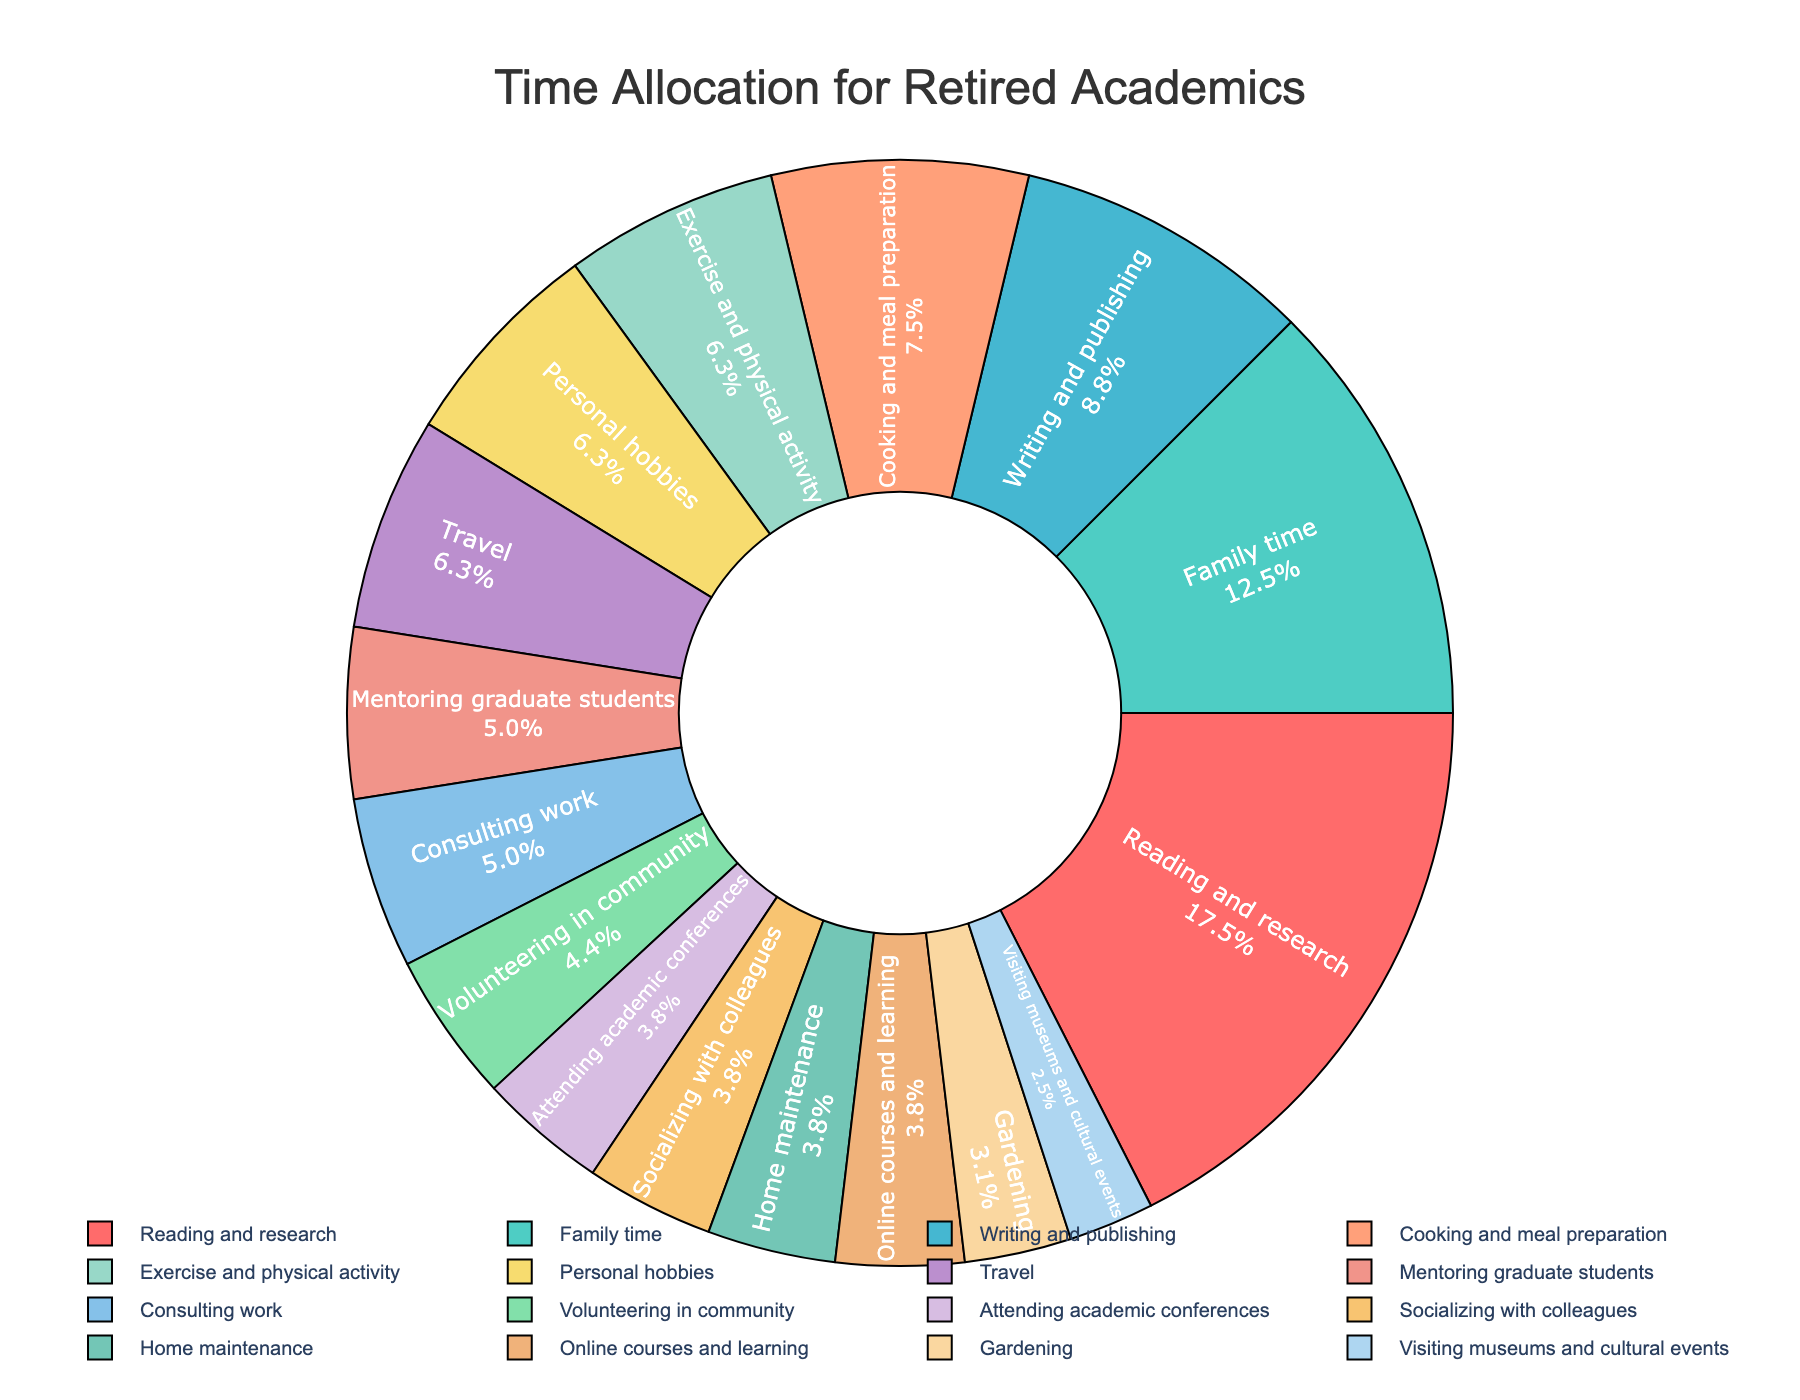What percentage of time is spent on reading and research? The pie chart includes labels that show the percentage of time spent on each activity. Locate the segment labeled "Reading and research," which shows 28 hours allocated. According to the chart, this corresponds to 28%.
Answer: 28% Which activity takes up more time, socializing with colleagues or consulting work? To compare these two activities, check the parts of the pie chart labeled "Socializing with colleagues" and "Consulting work." "Socializing with colleagues" is 6 hours while "Consulting work" is 8 hours, corresponding to a larger portion of the pie for consulting work.
Answer: Consulting work What is the combined percentage of time spent on exercise, personal hobbies, and travel? Identify the segments for "Exercise and physical activity" (10 hours), "Personal hobbies" (10 hours), and "Travel" (10 hours) on the pie chart. Sum these hours (10 + 10 + 10 = 30). Since the total is 100 hours, the combined percentage is (30/100) * 100%.
Answer: 30% What activity has the smallest allocated time and what percentage does this represent? Locate the smallest segment, labeled "Visiting museums and cultural events," which is allocated 4 hours. This can be read directly from the pie chart, and it represents 4% of the total time.
Answer: Visiting museums and cultural events, 4% Compare the time spent on cooking and meal preparation with family time? Check the segments for "Cooking and meal preparation" (12 hours) and "Family time" (20 hours). "Family time" takes up more hours and therefore a larger portion of the pie chart.
Answer: Family time How much more time is spent on reading and research compared to gardening? "Reading and research" is allocated 28 hours and "Gardening" is allocated 5 hours. Subtract the time for gardening from the time for reading (28 - 5 = 23).
Answer: 23 hours Which activities are given 6 hours each? Identify segments marked with 6 hours. These are "Attending academic conferences," "Socializing with colleagues," "Home maintenance," and "Online courses and learning."
Answer: Attending academic conferences, Socializing with colleagues, Home maintenance, Online courses and learning What is the average time spent on activities that are allocated exactly 10 hours? The activities with 10 hours are "Exercise and physical activity," "Personal hobbies," and "Travel." To find the average, sum these hours (10 + 10 + 10 = 30) and divide by the number of activities (3). Thus, the average is 30/3 = 10.
Answer: 10 hours What is the difference in time spent on mentoring graduate students compared to volunteering in the community? "Mentoring graduate students" is allocated 8 hours and "Volunteering in community" is allocated 7 hours. Subtract the volunteer hours from mentoring hours (8 - 7 = 1).
Answer: 1 hour 